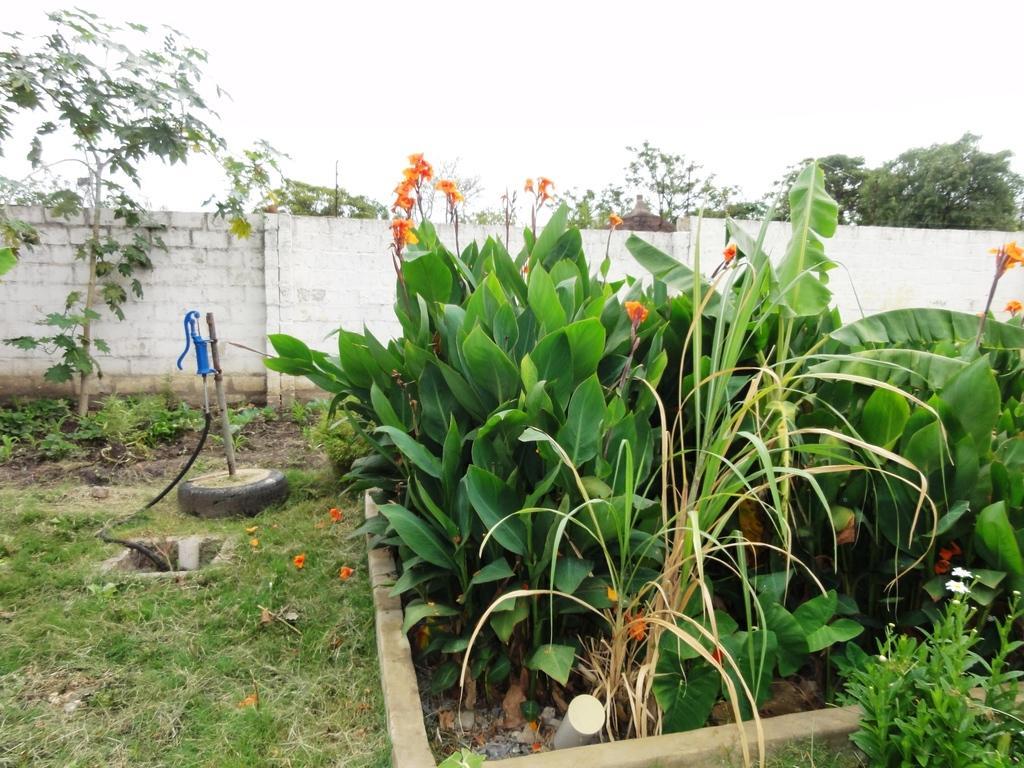Describe this image in one or two sentences. In this image there is a garden on the right side. In the garden there are plants with the flowers. In the background there is a wall. On the left side there is a blue colour pump. On the ground there is grass. At the top there is sky. 